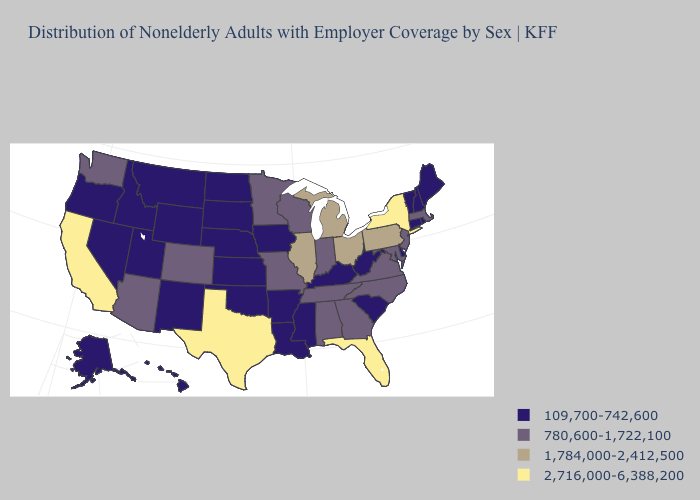What is the highest value in the MidWest ?
Be succinct. 1,784,000-2,412,500. Does the map have missing data?
Short answer required. No. Does Virginia have a higher value than South Dakota?
Concise answer only. Yes. Name the states that have a value in the range 1,784,000-2,412,500?
Answer briefly. Illinois, Michigan, Ohio, Pennsylvania. Among the states that border Ohio , which have the highest value?
Short answer required. Michigan, Pennsylvania. What is the highest value in the MidWest ?
Keep it brief. 1,784,000-2,412,500. Among the states that border Vermont , does Massachusetts have the lowest value?
Give a very brief answer. No. What is the lowest value in the USA?
Give a very brief answer. 109,700-742,600. Does the map have missing data?
Quick response, please. No. Does the map have missing data?
Answer briefly. No. What is the value of Oklahoma?
Short answer required. 109,700-742,600. Among the states that border Mississippi , which have the highest value?
Quick response, please. Alabama, Tennessee. Name the states that have a value in the range 1,784,000-2,412,500?
Concise answer only. Illinois, Michigan, Ohio, Pennsylvania. Name the states that have a value in the range 1,784,000-2,412,500?
Be succinct. Illinois, Michigan, Ohio, Pennsylvania. Name the states that have a value in the range 2,716,000-6,388,200?
Be succinct. California, Florida, New York, Texas. 